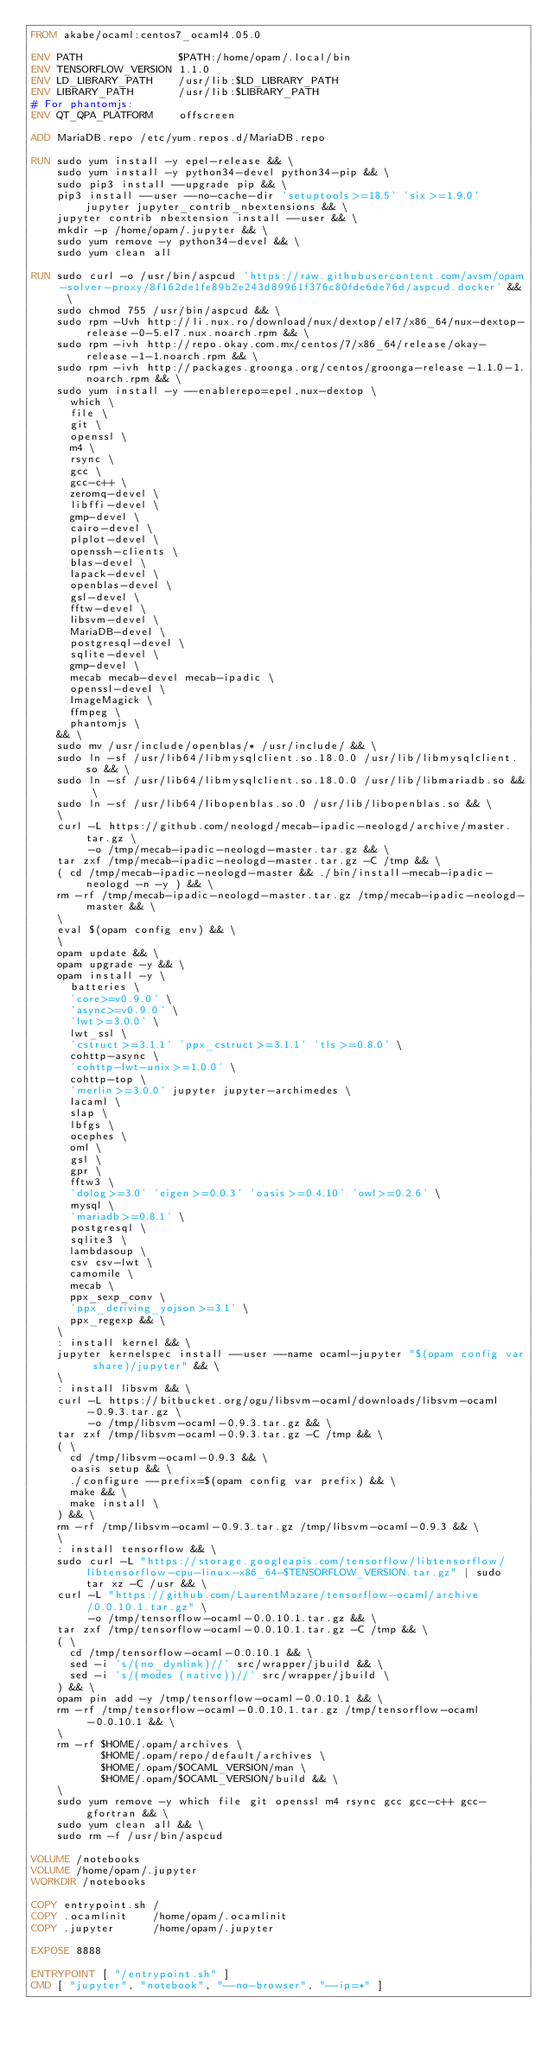Convert code to text. <code><loc_0><loc_0><loc_500><loc_500><_Dockerfile_>FROM akabe/ocaml:centos7_ocaml4.05.0

ENV PATH               $PATH:/home/opam/.local/bin
ENV TENSORFLOW_VERSION 1.1.0
ENV LD_LIBRARY_PATH    /usr/lib:$LD_LIBRARY_PATH
ENV LIBRARY_PATH       /usr/lib:$LIBRARY_PATH
# For phantomjs:
ENV QT_QPA_PLATFORM    offscreen

ADD MariaDB.repo /etc/yum.repos.d/MariaDB.repo

RUN sudo yum install -y epel-release && \
    sudo yum install -y python34-devel python34-pip && \
    sudo pip3 install --upgrade pip && \
    pip3 install --user --no-cache-dir 'setuptools>=18.5' 'six>=1.9.0' jupyter jupyter_contrib_nbextensions && \
    jupyter contrib nbextension install --user && \
    mkdir -p /home/opam/.jupyter && \
    sudo yum remove -y python34-devel && \
    sudo yum clean all

RUN sudo curl -o /usr/bin/aspcud 'https://raw.githubusercontent.com/avsm/opam-solver-proxy/8f162de1fe89b2e243d89961f376c80fde6de76d/aspcud.docker' && \
    sudo chmod 755 /usr/bin/aspcud && \
    sudo rpm -Uvh http://li.nux.ro/download/nux/dextop/el7/x86_64/nux-dextop-release-0-5.el7.nux.noarch.rpm && \
    sudo rpm -ivh http://repo.okay.com.mx/centos/7/x86_64/release/okay-release-1-1.noarch.rpm && \
    sudo rpm -ivh http://packages.groonga.org/centos/groonga-release-1.1.0-1.noarch.rpm && \
    sudo yum install -y --enablerepo=epel,nux-dextop \
      which \
      file \
      git \
      openssl \
      m4 \
      rsync \
      gcc \
      gcc-c++ \
      zeromq-devel \
      libffi-devel \
      gmp-devel \
      cairo-devel \
      plplot-devel \
      openssh-clients \
      blas-devel \
      lapack-devel \
      openblas-devel \
      gsl-devel \
      fftw-devel \
      libsvm-devel \
      MariaDB-devel \
      postgresql-devel \
      sqlite-devel \
      gmp-devel \
      mecab mecab-devel mecab-ipadic \
      openssl-devel \
      ImageMagick \
      ffmpeg \
      phantomjs \
    && \
    sudo mv /usr/include/openblas/* /usr/include/ && \
    sudo ln -sf /usr/lib64/libmysqlclient.so.18.0.0 /usr/lib/libmysqlclient.so && \
    sudo ln -sf /usr/lib64/libmysqlclient.so.18.0.0 /usr/lib/libmariadb.so && \
    sudo ln -sf /usr/lib64/libopenblas.so.0 /usr/lib/libopenblas.so && \
    \
    curl -L https://github.com/neologd/mecab-ipadic-neologd/archive/master.tar.gz \
         -o /tmp/mecab-ipadic-neologd-master.tar.gz && \
    tar zxf /tmp/mecab-ipadic-neologd-master.tar.gz -C /tmp && \
    ( cd /tmp/mecab-ipadic-neologd-master && ./bin/install-mecab-ipadic-neologd -n -y ) && \
    rm -rf /tmp/mecab-ipadic-neologd-master.tar.gz /tmp/mecab-ipadic-neologd-master && \
    \
    eval $(opam config env) && \
    \
    opam update && \
    opam upgrade -y && \
    opam install -y \
      batteries \
      'core>=v0.9.0' \
      'async>=v0.9.0' \
      'lwt>=3.0.0' \
      lwt_ssl \
      'cstruct>=3.1.1' 'ppx_cstruct>=3.1.1' 'tls>=0.8.0' \
      cohttp-async \
      'cohttp-lwt-unix>=1.0.0' \
      cohttp-top \
      'merlin>=3.0.0' jupyter jupyter-archimedes \
      lacaml \
      slap \
      lbfgs \
      ocephes \
      oml \
      gsl \
      gpr \
      fftw3 \
      'dolog>=3.0' 'eigen>=0.0.3' 'oasis>=0.4.10' 'owl>=0.2.6' \
      mysql \
      'mariadb>=0.8.1' \
      postgresql \
      sqlite3 \
      lambdasoup \
      csv csv-lwt \
      camomile \
      mecab \
      ppx_sexp_conv \
      'ppx_deriving_yojson>=3.1' \
      ppx_regexp && \
    \
    : install kernel && \
    jupyter kernelspec install --user --name ocaml-jupyter "$(opam config var share)/jupyter" && \
    \
    : install libsvm && \
    curl -L https://bitbucket.org/ogu/libsvm-ocaml/downloads/libsvm-ocaml-0.9.3.tar.gz \
         -o /tmp/libsvm-ocaml-0.9.3.tar.gz && \
    tar zxf /tmp/libsvm-ocaml-0.9.3.tar.gz -C /tmp && \
    ( \
      cd /tmp/libsvm-ocaml-0.9.3 && \
      oasis setup && \
      ./configure --prefix=$(opam config var prefix) && \
      make && \
      make install \
    ) && \
    rm -rf /tmp/libsvm-ocaml-0.9.3.tar.gz /tmp/libsvm-ocaml-0.9.3 && \
    \
    : install tensorflow && \
    sudo curl -L "https://storage.googleapis.com/tensorflow/libtensorflow/libtensorflow-cpu-linux-x86_64-$TENSORFLOW_VERSION.tar.gz" | sudo tar xz -C /usr && \
    curl -L "https://github.com/LaurentMazare/tensorflow-ocaml/archive/0.0.10.1.tar.gz" \
         -o /tmp/tensorflow-ocaml-0.0.10.1.tar.gz && \
    tar zxf /tmp/tensorflow-ocaml-0.0.10.1.tar.gz -C /tmp && \
    ( \
      cd /tmp/tensorflow-ocaml-0.0.10.1 && \
      sed -i 's/(no_dynlink)//' src/wrapper/jbuild && \
      sed -i 's/(modes (native))//' src/wrapper/jbuild \
    ) && \
    opam pin add -y /tmp/tensorflow-ocaml-0.0.10.1 && \
    rm -rf /tmp/tensorflow-ocaml-0.0.10.1.tar.gz /tmp/tensorflow-ocaml-0.0.10.1 && \
    \
    rm -rf $HOME/.opam/archives \
           $HOME/.opam/repo/default/archives \
           $HOME/.opam/$OCAML_VERSION/man \
           $HOME/.opam/$OCAML_VERSION/build && \
    \
    sudo yum remove -y which file git openssl m4 rsync gcc gcc-c++ gcc-gfortran && \
    sudo yum clean all && \
    sudo rm -f /usr/bin/aspcud

VOLUME /notebooks
VOLUME /home/opam/.jupyter
WORKDIR /notebooks

COPY entrypoint.sh /
COPY .ocamlinit    /home/opam/.ocamlinit
COPY .jupyter      /home/opam/.jupyter

EXPOSE 8888

ENTRYPOINT [ "/entrypoint.sh" ]
CMD [ "jupyter", "notebook", "--no-browser", "--ip=*" ]
</code> 